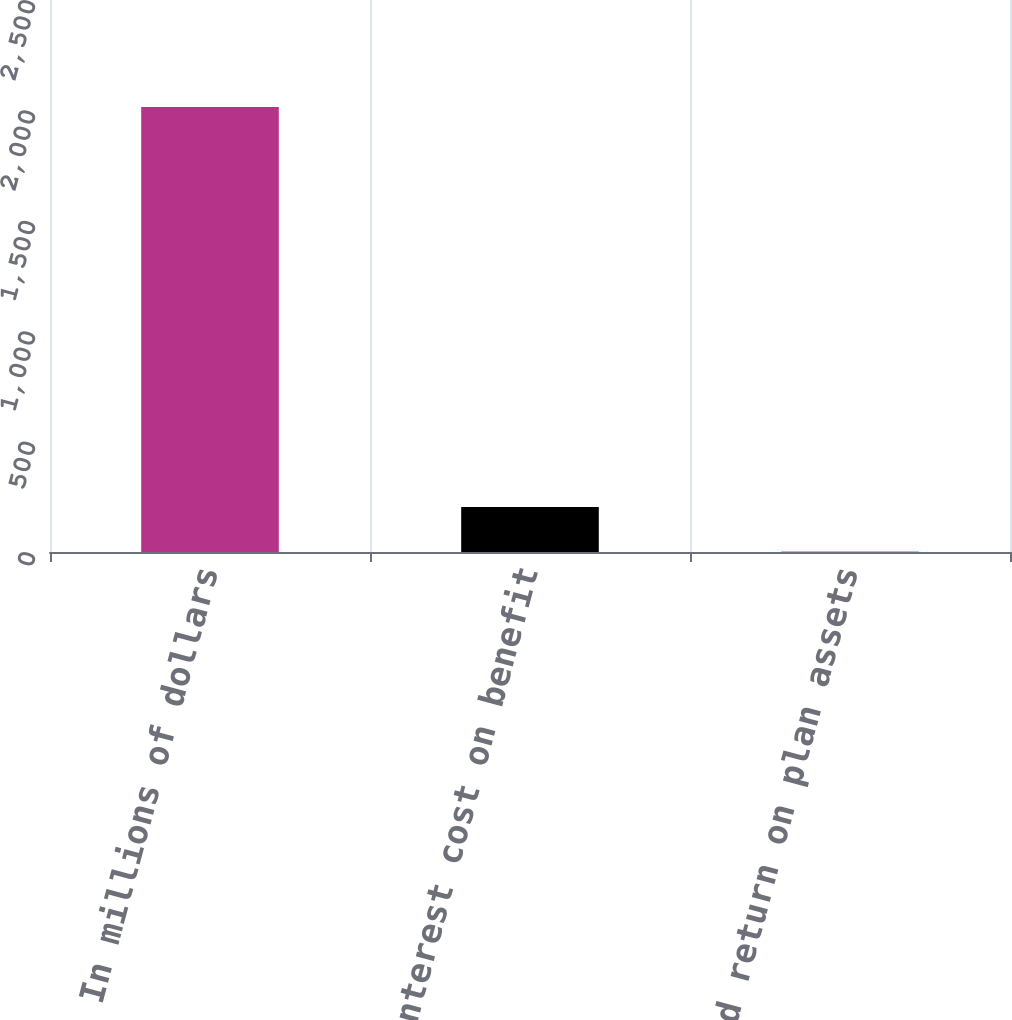Convert chart. <chart><loc_0><loc_0><loc_500><loc_500><bar_chart><fcel>In millions of dollars<fcel>Interest cost on benefit<fcel>Expected return on plan assets<nl><fcel>2015<fcel>204.2<fcel>3<nl></chart> 